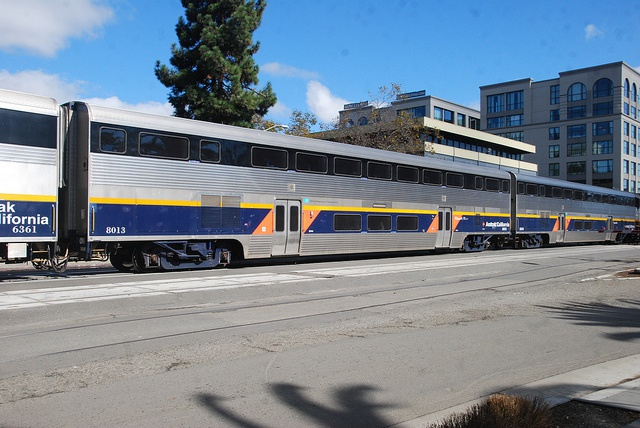Describe the objects in this image and their specific colors. I can see a train in lightgray, black, darkgray, and navy tones in this image. 